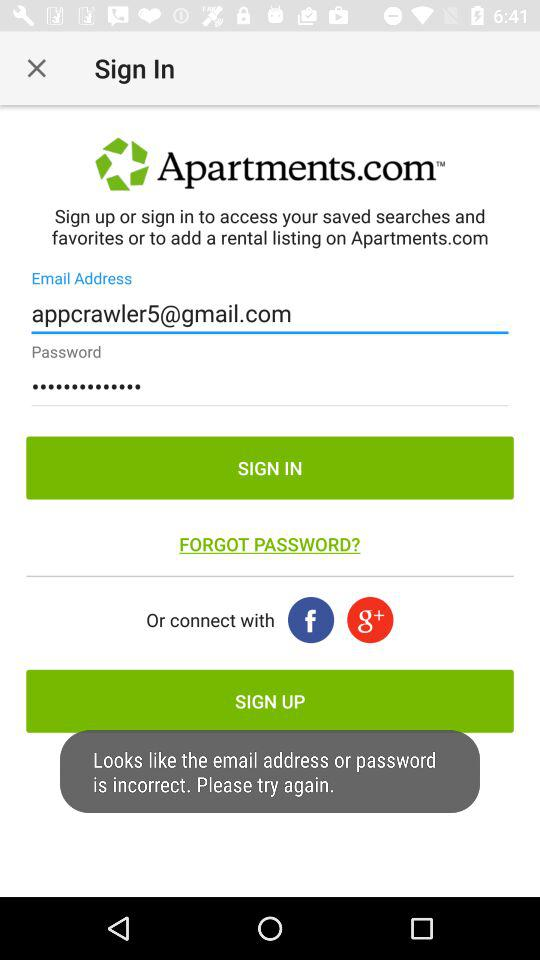What is the entered email address? The email address is appcrawler5@gmail.com. 